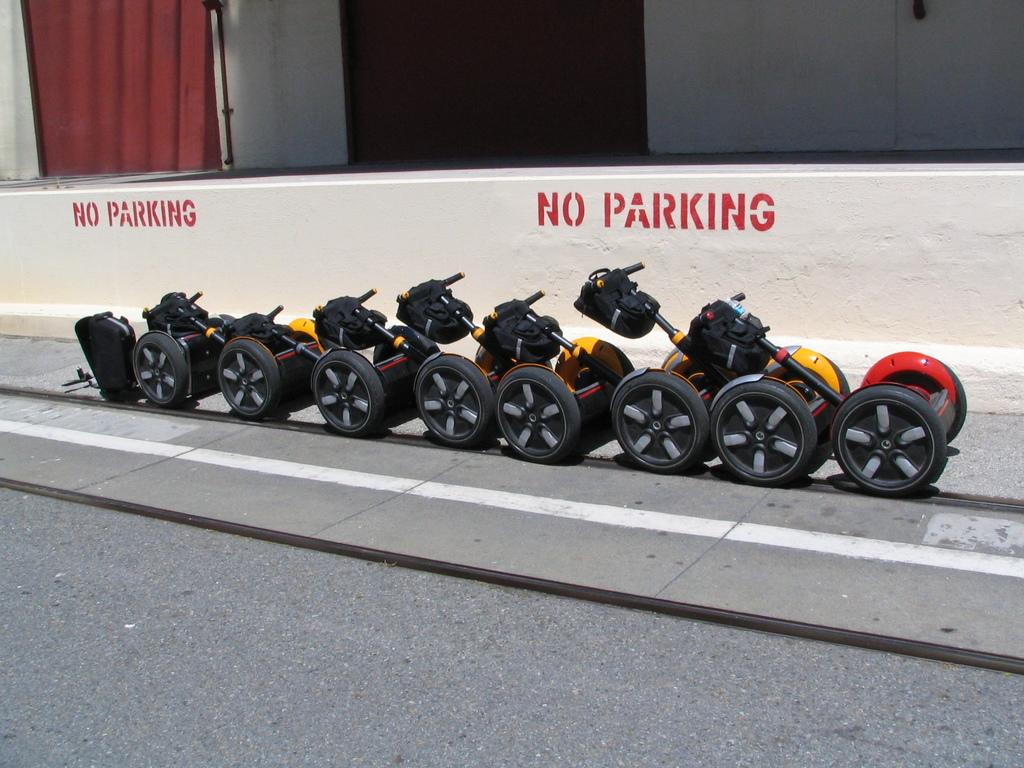What type of vehicles are in the image? There are self-balancing scooters in the image. Where are the scooters located? The scooters are on the side of the road. What else can be seen in the image besides the scooters? There is a building visible in the image. Is there a stream running through the downtown area in the image? There is no stream or downtown area present in the image; it features self-balancing scooters on the side of the road and a building in the background. 